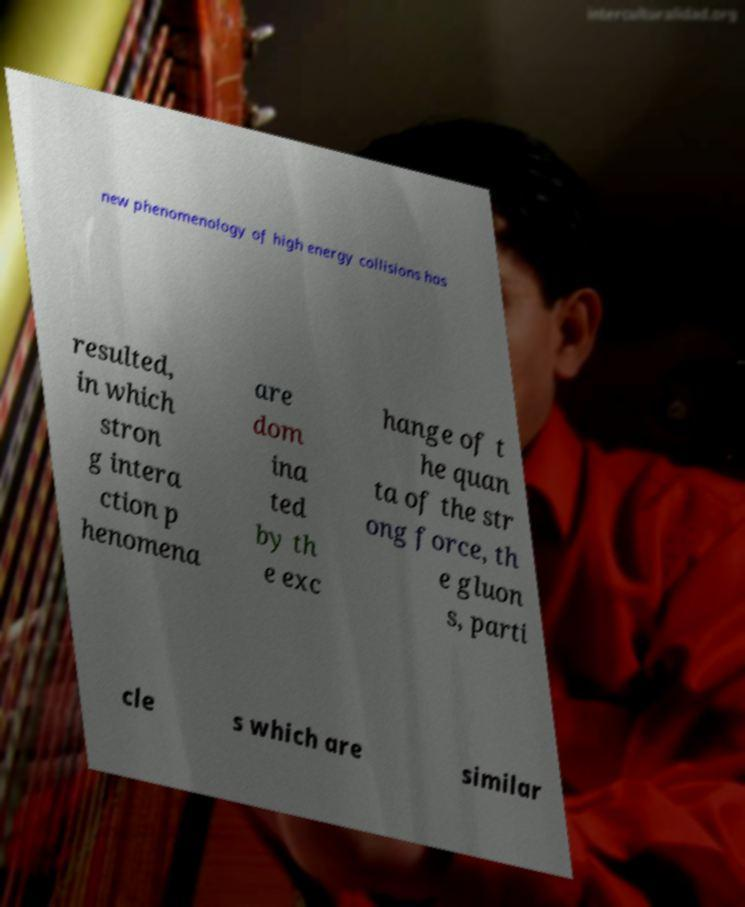For documentation purposes, I need the text within this image transcribed. Could you provide that? new phenomenology of high energy collisions has resulted, in which stron g intera ction p henomena are dom ina ted by th e exc hange of t he quan ta of the str ong force, th e gluon s, parti cle s which are similar 